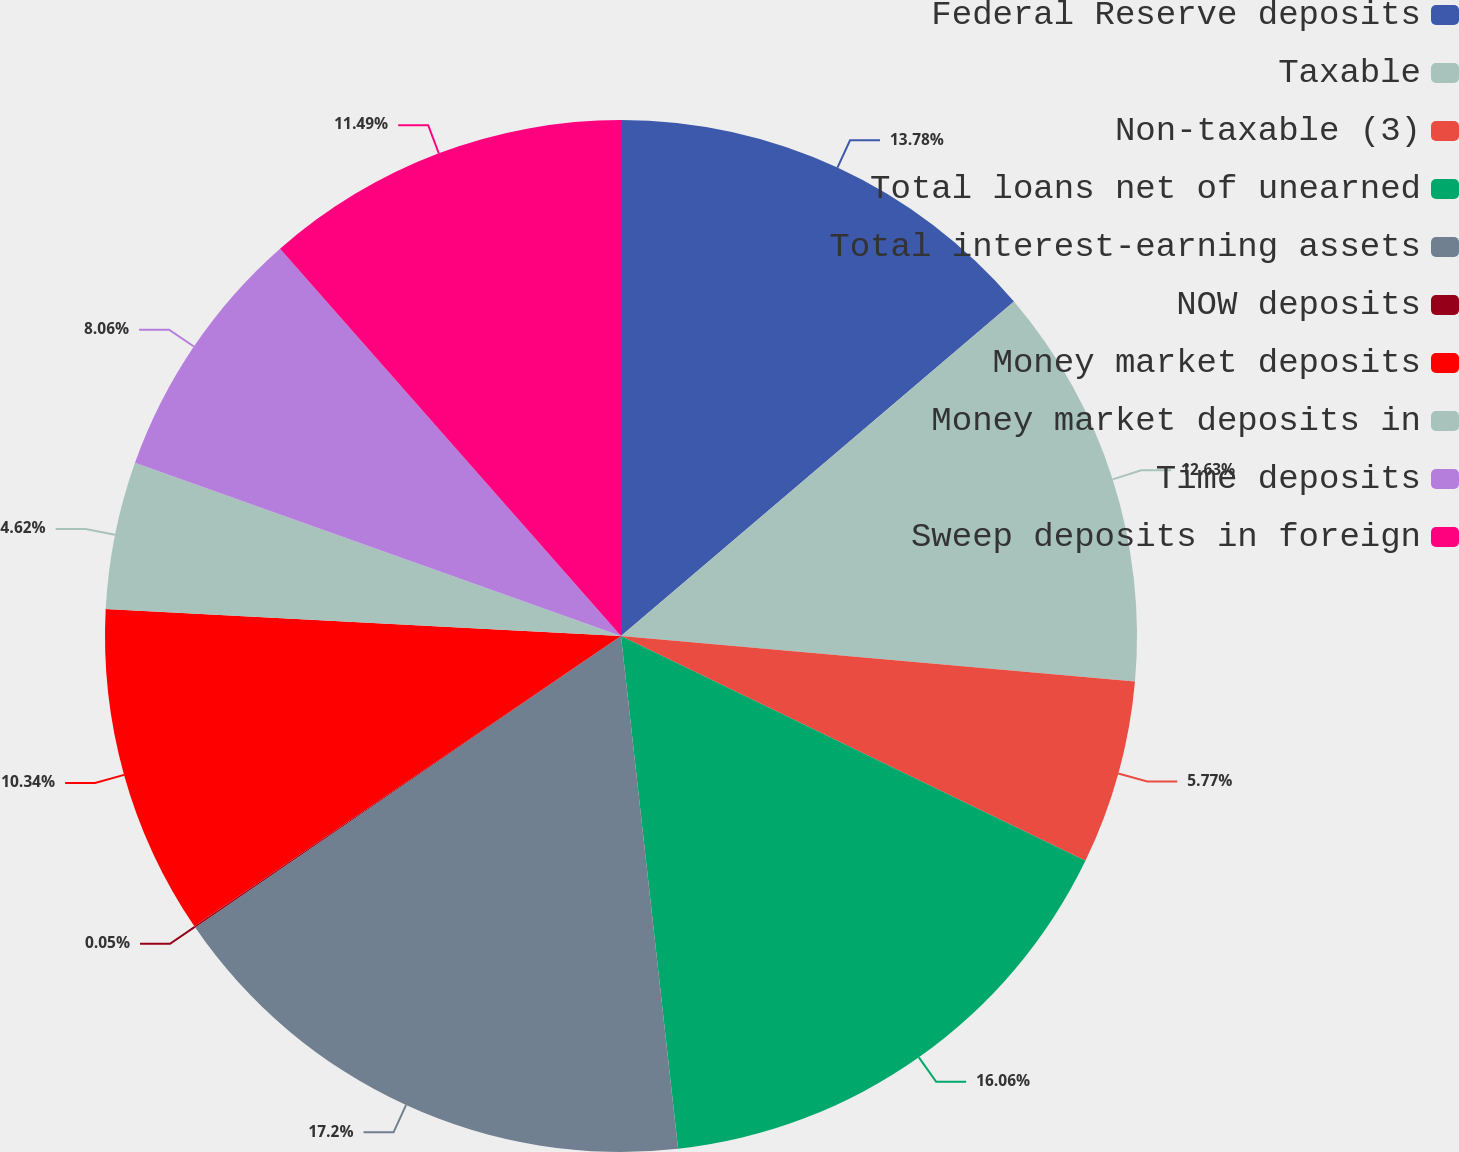Convert chart to OTSL. <chart><loc_0><loc_0><loc_500><loc_500><pie_chart><fcel>Federal Reserve deposits<fcel>Taxable<fcel>Non-taxable (3)<fcel>Total loans net of unearned<fcel>Total interest-earning assets<fcel>NOW deposits<fcel>Money market deposits<fcel>Money market deposits in<fcel>Time deposits<fcel>Sweep deposits in foreign<nl><fcel>13.78%<fcel>12.63%<fcel>5.77%<fcel>16.06%<fcel>17.21%<fcel>0.05%<fcel>10.34%<fcel>4.62%<fcel>8.06%<fcel>11.49%<nl></chart> 